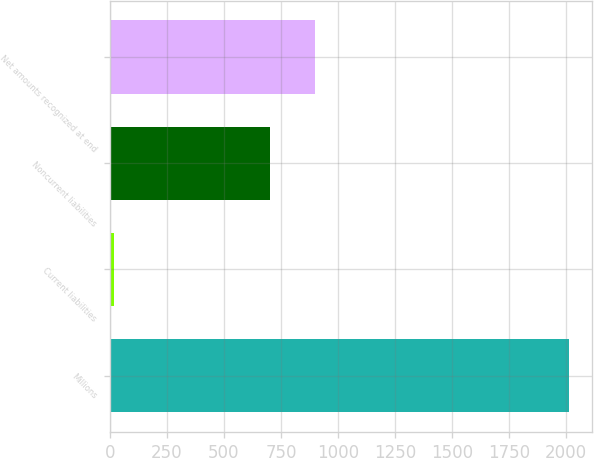Convert chart. <chart><loc_0><loc_0><loc_500><loc_500><bar_chart><fcel>Millions<fcel>Current liabilities<fcel>Noncurrent liabilities<fcel>Net amounts recognized at end<nl><fcel>2012<fcel>16<fcel>701<fcel>900.6<nl></chart> 